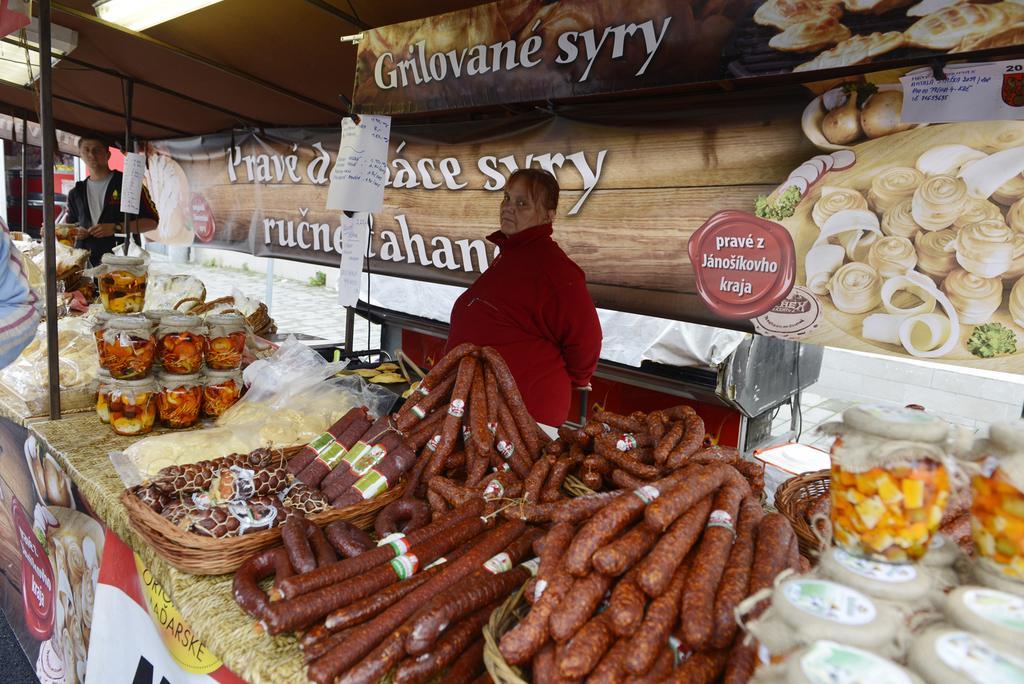In one or two sentences, can you explain what this image depicts? In this image, we can see a stall. At the bottom, we can see eatable things and items. In the middle, we can see two people are standing. Here we can see banners. Top of the image, we can see light, papers and rods. 